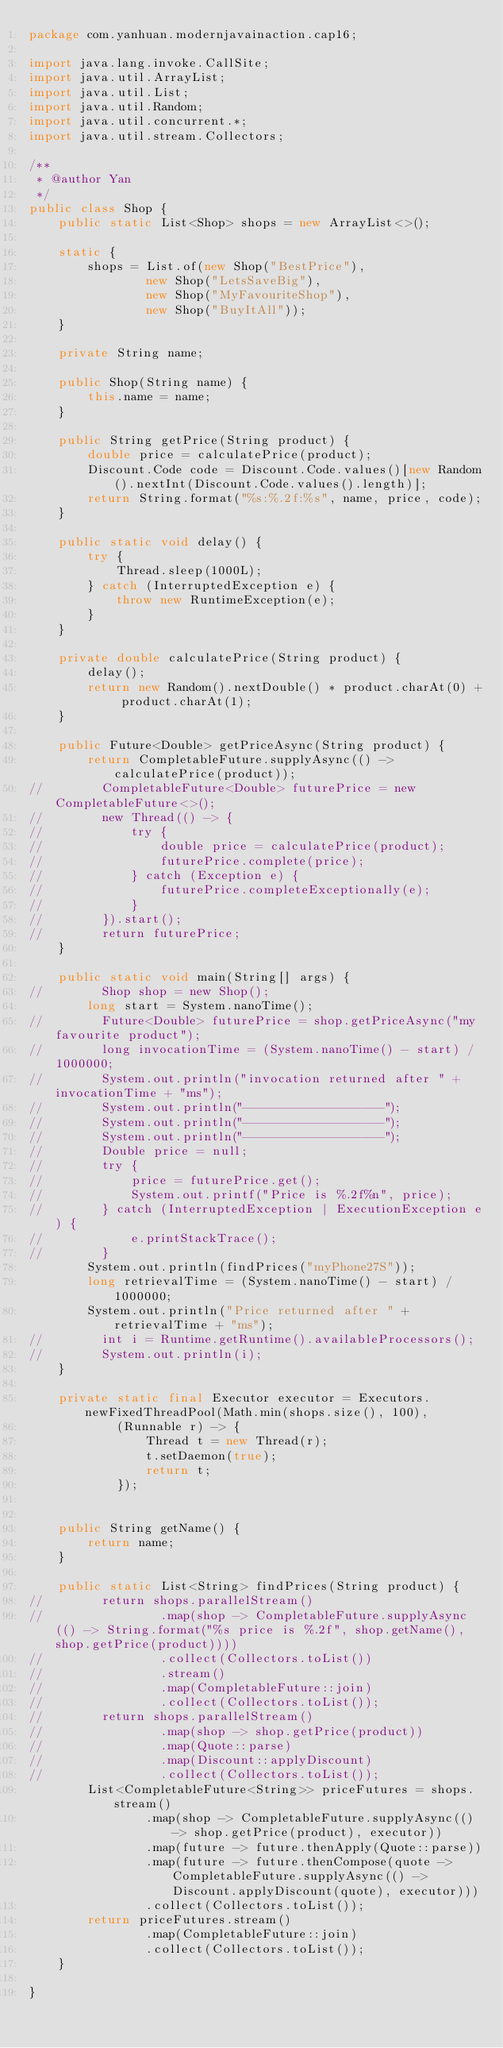Convert code to text. <code><loc_0><loc_0><loc_500><loc_500><_Java_>package com.yanhuan.modernjavainaction.cap16;

import java.lang.invoke.CallSite;
import java.util.ArrayList;
import java.util.List;
import java.util.Random;
import java.util.concurrent.*;
import java.util.stream.Collectors;

/**
 * @author Yan
 */
public class Shop {
    public static List<Shop> shops = new ArrayList<>();

    static {
        shops = List.of(new Shop("BestPrice"),
                new Shop("LetsSaveBig"),
                new Shop("MyFavouriteShop"),
                new Shop("BuyItAll"));
    }

    private String name;

    public Shop(String name) {
        this.name = name;
    }

    public String getPrice(String product) {
        double price = calculatePrice(product);
        Discount.Code code = Discount.Code.values()[new Random().nextInt(Discount.Code.values().length)];
        return String.format("%s:%.2f:%s", name, price, code);
    }

    public static void delay() {
        try {
            Thread.sleep(1000L);
        } catch (InterruptedException e) {
            throw new RuntimeException(e);
        }
    }

    private double calculatePrice(String product) {
        delay();
        return new Random().nextDouble() * product.charAt(0) + product.charAt(1);
    }

    public Future<Double> getPriceAsync(String product) {
        return CompletableFuture.supplyAsync(() -> calculatePrice(product));
//        CompletableFuture<Double> futurePrice = new CompletableFuture<>();
//        new Thread(() -> {
//            try {
//                double price = calculatePrice(product);
//                futurePrice.complete(price);
//            } catch (Exception e) {
//                futurePrice.completeExceptionally(e);
//            }
//        }).start();
//        return futurePrice;
    }

    public static void main(String[] args) {
//        Shop shop = new Shop();
        long start = System.nanoTime();
//        Future<Double> futurePrice = shop.getPriceAsync("my favourite product");
//        long invocationTime = (System.nanoTime() - start) / 1000000;
//        System.out.println("invocation returned after " + invocationTime + "ms");
//        System.out.println("------------------");
//        System.out.println("------------------");
//        System.out.println("------------------");
//        Double price = null;
//        try {
//            price = futurePrice.get();
//            System.out.printf("Price is %.2f%n", price);
//        } catch (InterruptedException | ExecutionException e) {
//            e.printStackTrace();
//        }
        System.out.println(findPrices("myPhone27S"));
        long retrievalTime = (System.nanoTime() - start) / 1000000;
        System.out.println("Price returned after " + retrievalTime + "ms");
//        int i = Runtime.getRuntime().availableProcessors();
//        System.out.println(i);
    }

    private static final Executor executor = Executors.newFixedThreadPool(Math.min(shops.size(), 100),
            (Runnable r) -> {
                Thread t = new Thread(r);
                t.setDaemon(true);
                return t;
            });


    public String getName() {
        return name;
    }

    public static List<String> findPrices(String product) {
//        return shops.parallelStream()
//                .map(shop -> CompletableFuture.supplyAsync(() -> String.format("%s price is %.2f", shop.getName(), shop.getPrice(product))))
//                .collect(Collectors.toList())
//                .stream()
//                .map(CompletableFuture::join)
//                .collect(Collectors.toList());
//        return shops.parallelStream()
//                .map(shop -> shop.getPrice(product))
//                .map(Quote::parse)
//                .map(Discount::applyDiscount)
//                .collect(Collectors.toList());
        List<CompletableFuture<String>> priceFutures = shops.stream()
                .map(shop -> CompletableFuture.supplyAsync(() -> shop.getPrice(product), executor))
                .map(future -> future.thenApply(Quote::parse))
                .map(future -> future.thenCompose(quote -> CompletableFuture.supplyAsync(() -> Discount.applyDiscount(quote), executor)))
                .collect(Collectors.toList());
        return priceFutures.stream()
                .map(CompletableFuture::join)
                .collect(Collectors.toList());
    }

}</code> 